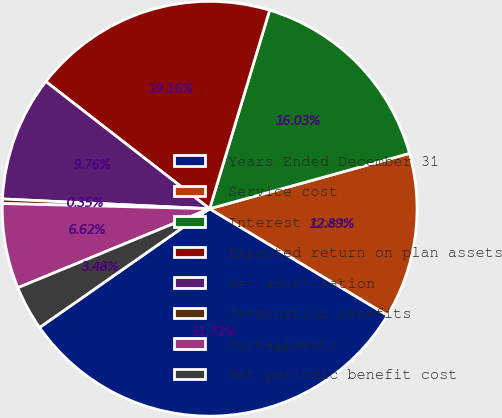<chart> <loc_0><loc_0><loc_500><loc_500><pie_chart><fcel>Years Ended December 31<fcel>Service cost<fcel>Interest cost<fcel>Expected return on plan assets<fcel>Net amortization<fcel>Termination benefits<fcel>Curtailments<fcel>Net periodic benefit cost<nl><fcel>31.71%<fcel>12.89%<fcel>16.03%<fcel>19.16%<fcel>9.76%<fcel>0.35%<fcel>6.62%<fcel>3.48%<nl></chart> 